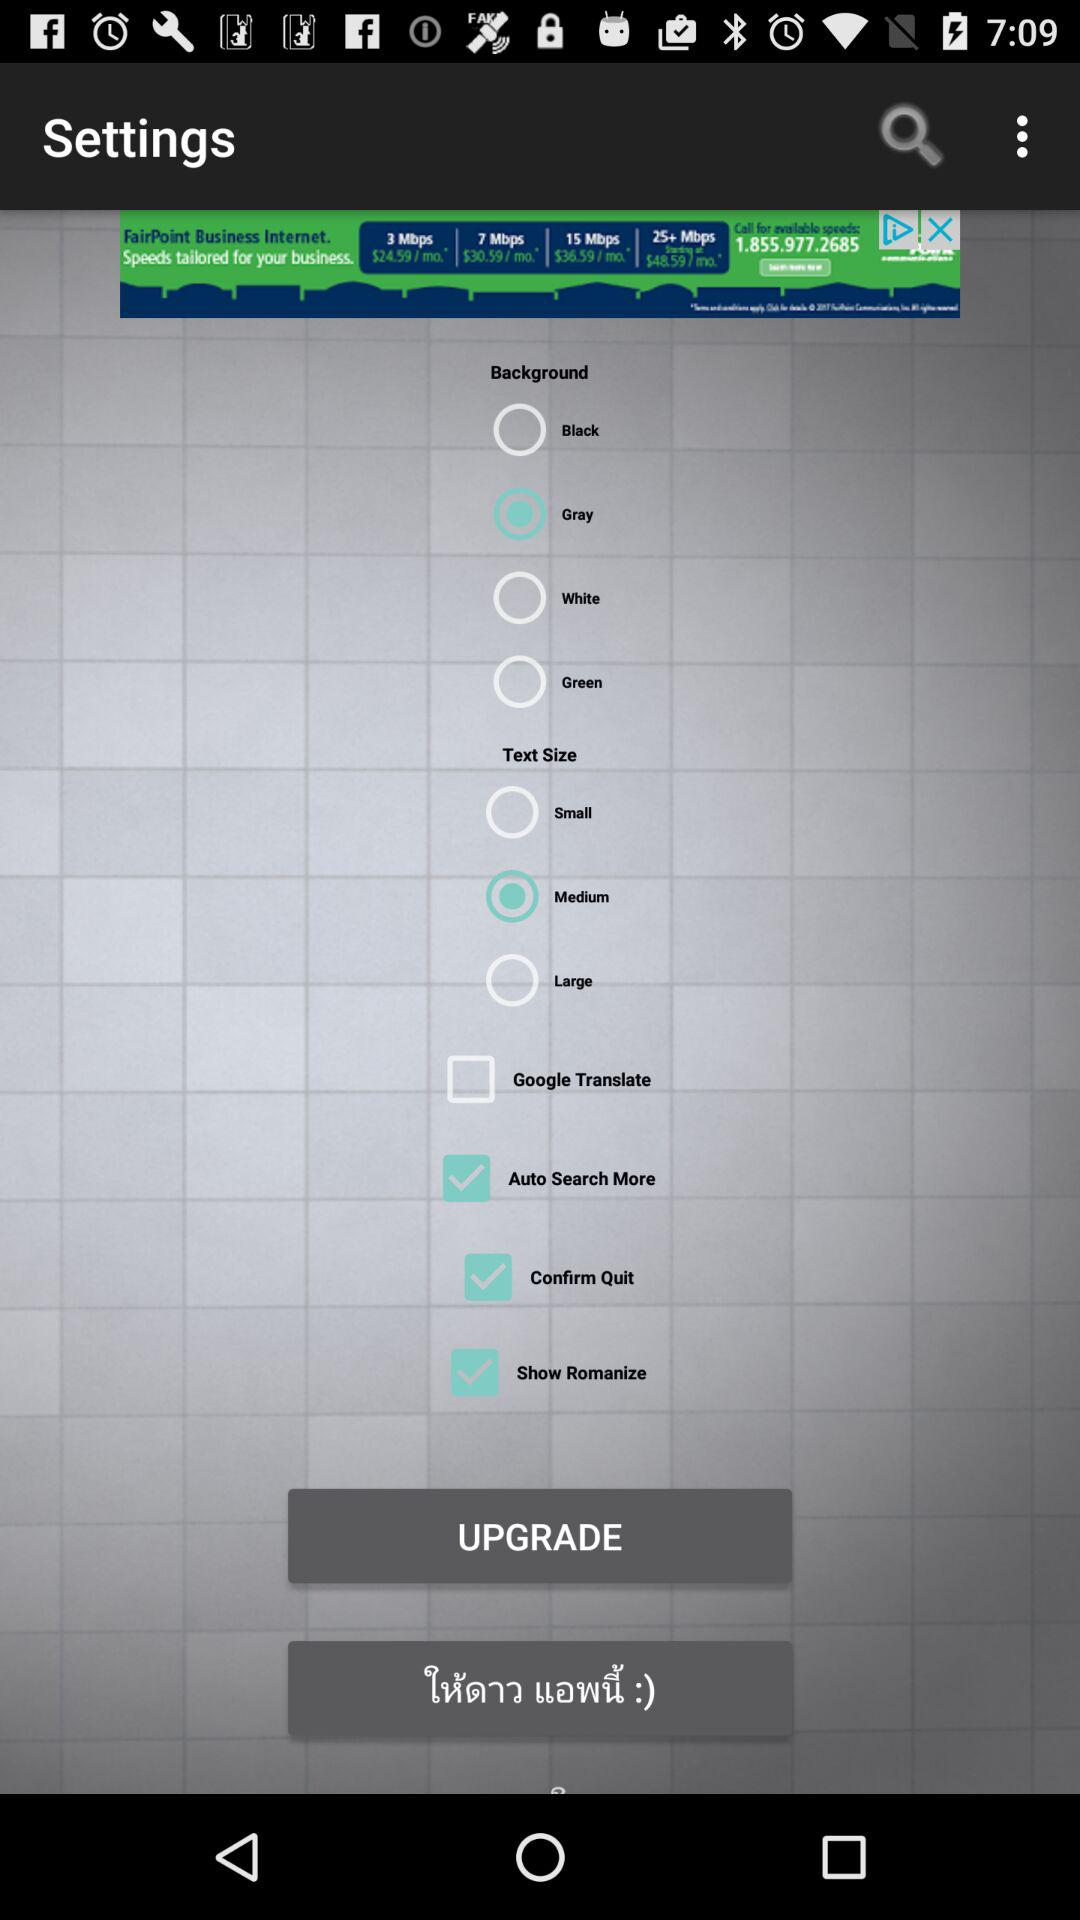What option has been selected in text size? The selected option is "Medium". 